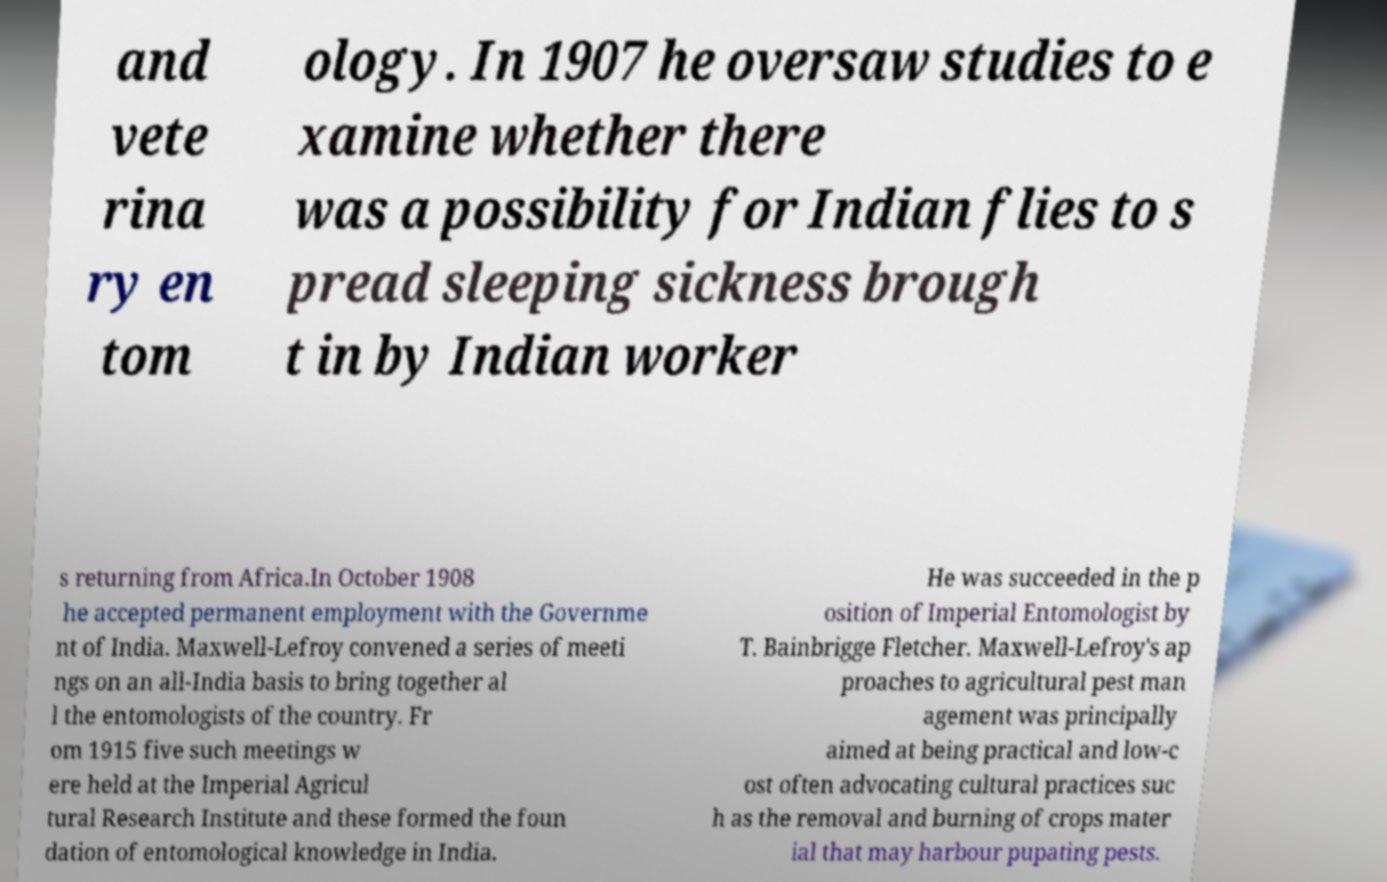Please identify and transcribe the text found in this image. and vete rina ry en tom ology. In 1907 he oversaw studies to e xamine whether there was a possibility for Indian flies to s pread sleeping sickness brough t in by Indian worker s returning from Africa.In October 1908 he accepted permanent employment with the Governme nt of India. Maxwell-Lefroy convened a series of meeti ngs on an all-India basis to bring together al l the entomologists of the country. Fr om 1915 five such meetings w ere held at the Imperial Agricul tural Research Institute and these formed the foun dation of entomological knowledge in India. He was succeeded in the p osition of Imperial Entomologist by T. Bainbrigge Fletcher. Maxwell-Lefroy's ap proaches to agricultural pest man agement was principally aimed at being practical and low-c ost often advocating cultural practices suc h as the removal and burning of crops mater ial that may harbour pupating pests. 